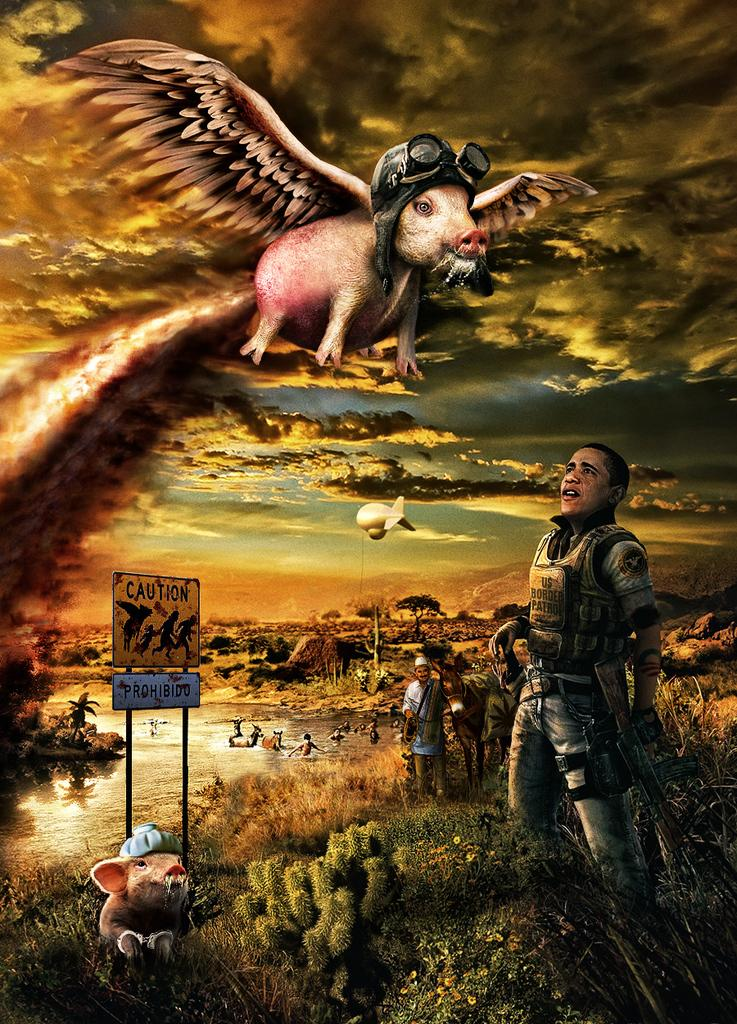What are the people in the image wearing? The people in the image are wearing clothes. What type of terrain is visible in the image? There is grass and water visible in the image. What objects can be seen in the image besides the people? There is a board, a pole, an animal, and a rifle in the image. What is the weather like in the image? The sky is cloudy, and there is smoke in the image, suggesting a potentially smoky or foggy atmosphere. What does the sleet taste like in the image? There is no mention of sleet in the image, so it cannot be determined what it might taste like. How does the animal breathe in the image? The image does not show the animal's breathing, so it cannot be determined how it breathes. 